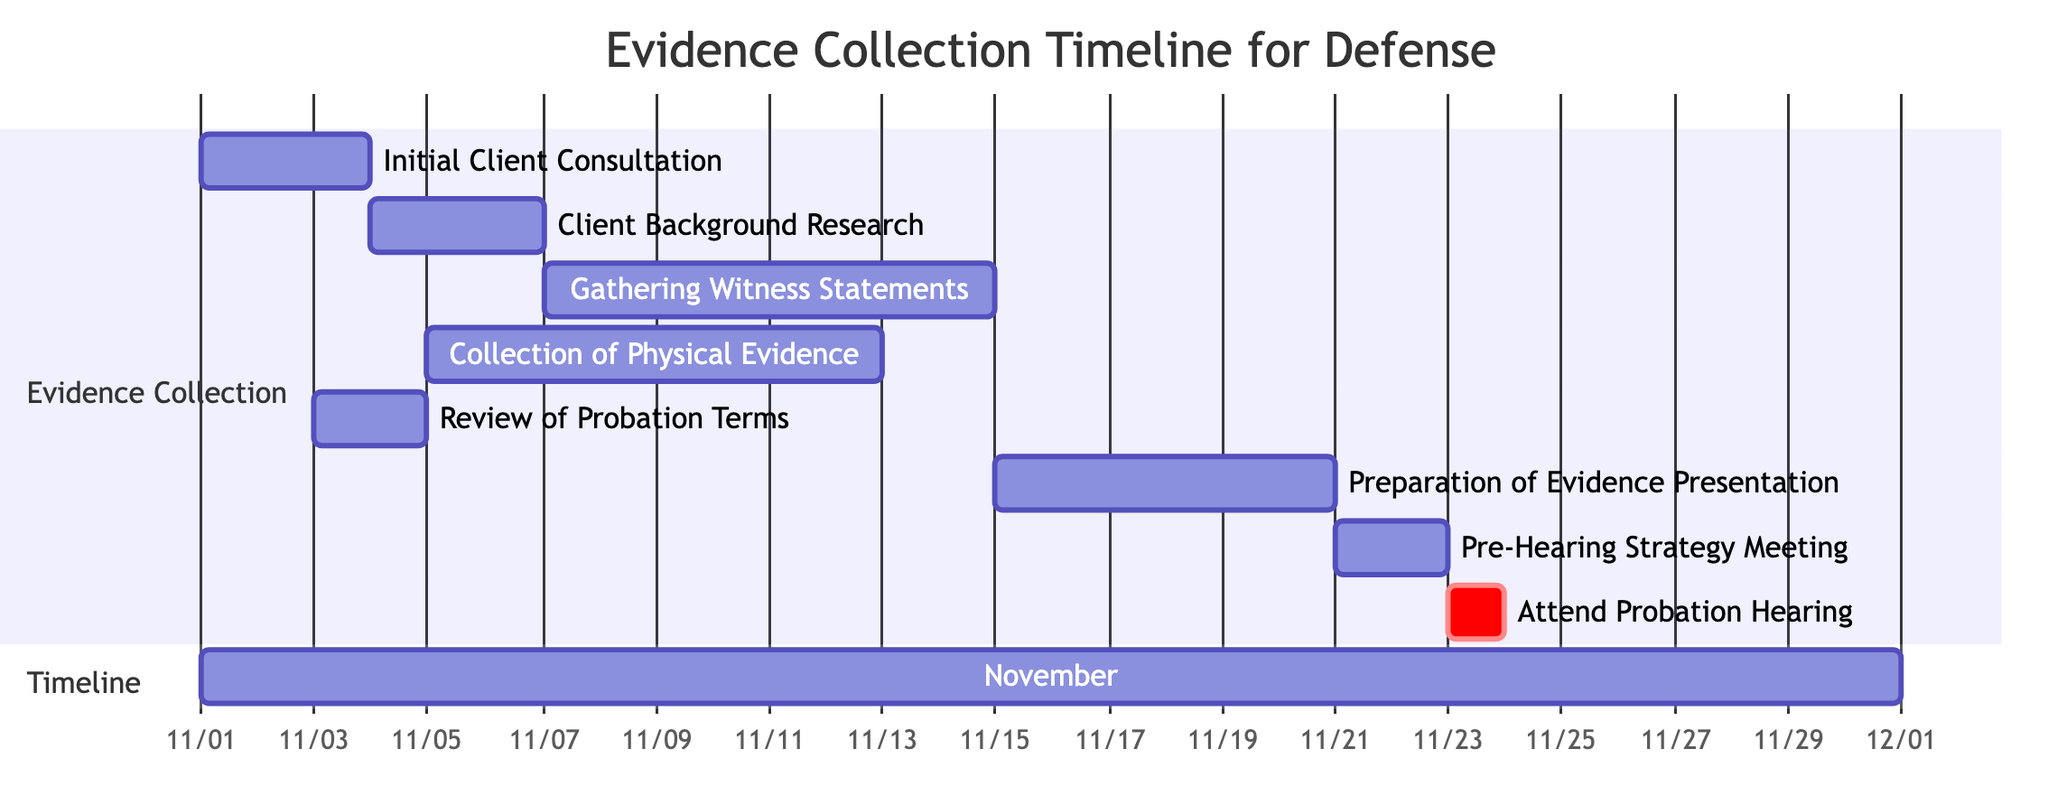What is the duration of the "Initial Client Consultation"? The task "Initial Client Consultation" starts on November 1, 2023, and ends on November 3, 2023. This means it lasts for a total of 3 days.
Answer: 3 days What task is scheduled to occur right after "Review of Probation Terms"? "Review of Probation Terms" ends on November 4, 2023, and immediately afterwards, "Client Background Research" starts on the same day, November 4, 2023.
Answer: Client Background Research How many days are allocated for "Gathering Witness Statements"? The task "Gathering Witness Statements" starts on November 7, 2023, and ends on November 14, 2023, which gives it a duration of 8 days.
Answer: 8 days Which task requires the earliest start date? The task with the earliest start date is "Initial Client Consultation," which begins on November 1, 2023.
Answer: Initial Client Consultation What is the last task in the timeline? The last task in the timeline is "Attend Probation Hearing," which occurs on November 23, 2023.
Answer: Attend Probation Hearing How many tasks overlap in the timeline? At least two tasks overlap: "Gathering Witness Statements" (November 7-14) overlaps with "Collection of Physical Evidence" (November 5-12). Additionally, "Preparation of Evidence Presentation" starts before the "Gathering Witness Statements" ends, as it occurs from November 15-20 after both previous tasks. Therefore, at least 3 tasks overlap at various points in the timeline.
Answer: 3 tasks What is the start date of the "Preparation of Evidence Presentation"? The task "Preparation of Evidence Presentation" starts on November 15, 2023.
Answer: November 15, 2023 Which task is critical? The task "Attend Probation Hearing" is marked as critical, indicating its importance in the timeline.
Answer: Attend Probation Hearing 